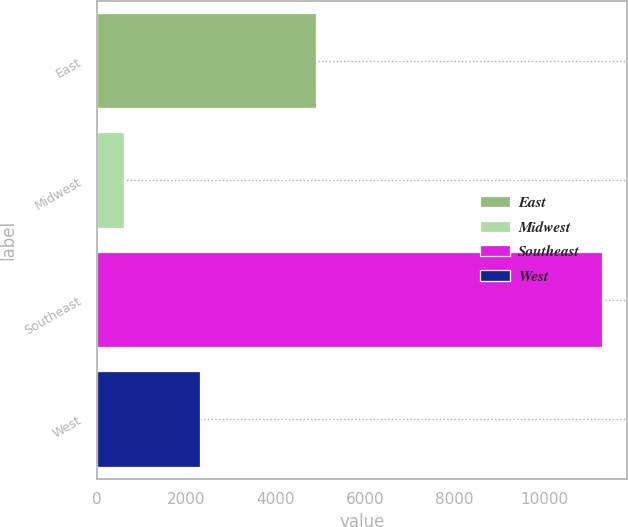Convert chart. <chart><loc_0><loc_0><loc_500><loc_500><bar_chart><fcel>East<fcel>Midwest<fcel>Southeast<fcel>West<nl><fcel>4900<fcel>600<fcel>11300<fcel>2300<nl></chart> 